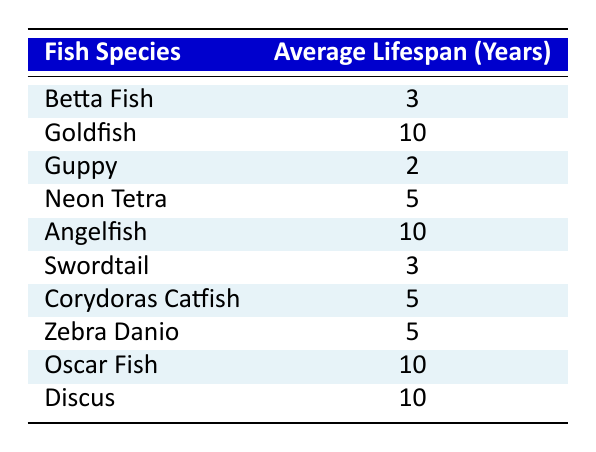What is the average lifespan of a Goldfish? The table lists the average lifespan of Goldfish as 10 years.
Answer: 10 years How long can a Betta Fish live in an aquarium? According to the table, a Betta Fish has an average lifespan of 3 years.
Answer: 3 years Which fish species listed has the shortest lifespan? The Guppy has the shortest lifespan listed, which is 2 years.
Answer: Guppy How many fish species have an average lifespan of 5 years? The table shows that three fish species—Neon Tetra, Corydoras Catfish, and Zebra Danio—each have an average lifespan of 5 years.
Answer: 3 species Is it true that both Goldfish and Angelfish have the same lifespan? The table states that Goldfish have a lifespan of 10 years and Angelfish also have a lifespan of 10 years, so it is true.
Answer: Yes What is the total average lifespan of the fish species that have an average lifespan of 10 years? The fish species with an average lifespan of 10 years are Goldfish, Angelfish, Oscar Fish, and Discus. Adding them together: 10 + 10 + 10 + 10 = 40 years.
Answer: 40 years If you average the lifespans of the Swordtail and Betta Fish, what is the result? The average lifespan of Swordtail is 3 years, and for Betta Fish, it's 3 years. Summing them gives 3 + 3 = 6, and dividing by 2 for the average gives 6 / 2 = 3 years.
Answer: 3 years What fish species in the table has the longest lifespan? The table shows that Goldfish, Angelfish, Oscar Fish, and Discus all have the longest lifespan, which is 10 years.
Answer: Goldfish, Angelfish, Oscar Fish, and Discus Is there any species that has an average lifespan greater than 5 years but less than 10 years? The only species fitting this criterion is the Neon Tetra, which has an average lifespan of 5 years, thus there are none fitting strictly between these ranges.
Answer: No 